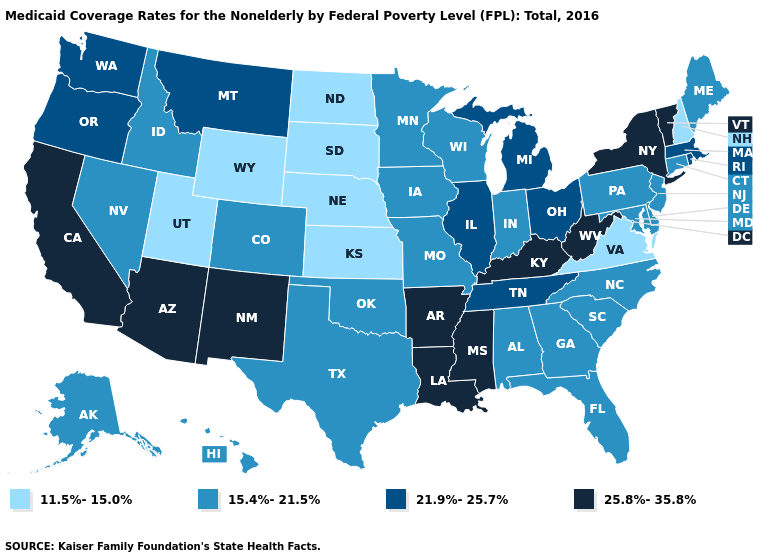What is the value of Georgia?
Be succinct. 15.4%-21.5%. Which states have the lowest value in the South?
Keep it brief. Virginia. What is the highest value in the USA?
Quick response, please. 25.8%-35.8%. What is the value of Arizona?
Concise answer only. 25.8%-35.8%. Is the legend a continuous bar?
Quick response, please. No. Does Missouri have a higher value than Delaware?
Answer briefly. No. Among the states that border Rhode Island , does Massachusetts have the highest value?
Be succinct. Yes. Does Kentucky have the same value as Mississippi?
Be succinct. Yes. How many symbols are there in the legend?
Give a very brief answer. 4. What is the value of New Mexico?
Keep it brief. 25.8%-35.8%. Which states have the highest value in the USA?
Be succinct. Arizona, Arkansas, California, Kentucky, Louisiana, Mississippi, New Mexico, New York, Vermont, West Virginia. What is the value of South Dakota?
Quick response, please. 11.5%-15.0%. What is the lowest value in states that border Mississippi?
Concise answer only. 15.4%-21.5%. Does the first symbol in the legend represent the smallest category?
Short answer required. Yes. Name the states that have a value in the range 21.9%-25.7%?
Answer briefly. Illinois, Massachusetts, Michigan, Montana, Ohio, Oregon, Rhode Island, Tennessee, Washington. 